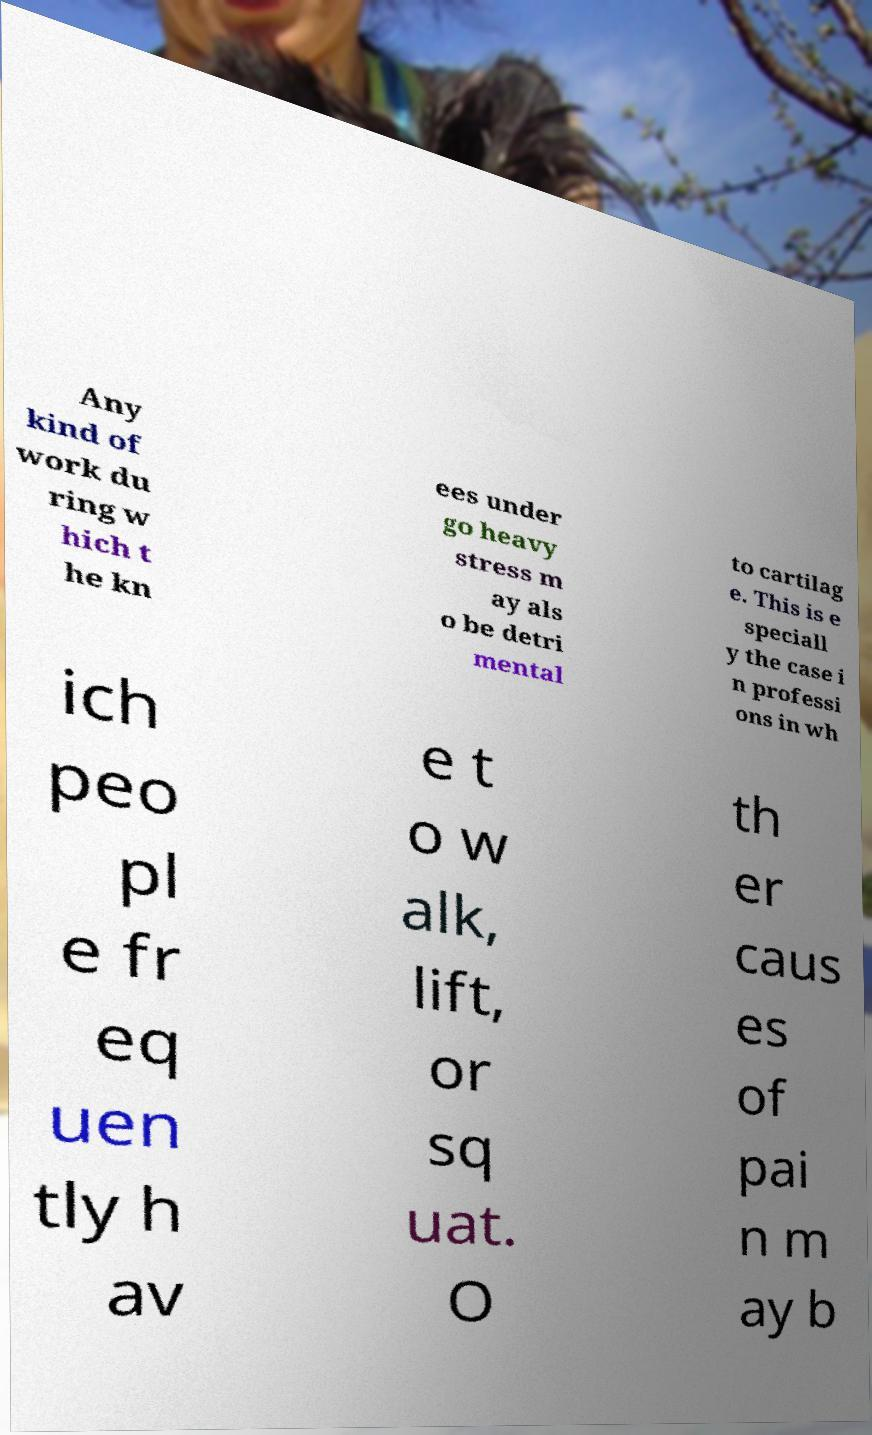Please read and relay the text visible in this image. What does it say? Any kind of work du ring w hich t he kn ees under go heavy stress m ay als o be detri mental to cartilag e. This is e speciall y the case i n professi ons in wh ich peo pl e fr eq uen tly h av e t o w alk, lift, or sq uat. O th er caus es of pai n m ay b 